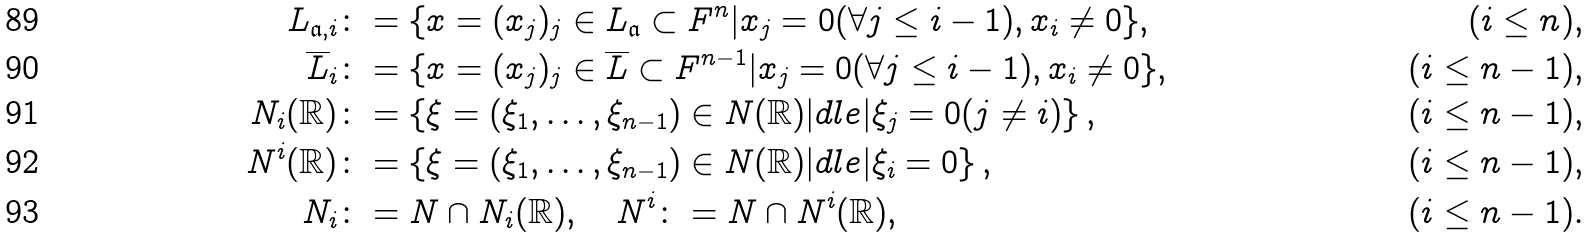<formula> <loc_0><loc_0><loc_500><loc_500>L _ { \mathfrak a , i } & \colon = \{ x = ( x _ { j } ) _ { j } \in L _ { \mathfrak a } \subset F ^ { n } | x _ { j } = 0 ( \forall j \leq i - 1 ) , x _ { i } \neq 0 \} , & ( i \leq n ) , \\ \overline { L } _ { i } & \colon = \{ x = ( x _ { j } ) _ { j } \in \overline { L } \subset F ^ { n - 1 } | x _ { j } = 0 ( \forall j \leq i - 1 ) , x _ { i } \neq 0 \} , & ( i \leq n - 1 ) , \\ N _ { i } ( \mathbb { R } ) & \colon = \left \{ \xi = ( \xi _ { 1 } , \dots , \xi _ { n - 1 } ) \in N ( \mathbb { R } ) | d l e | \xi _ { j } = 0 ( j \neq i ) \right \} , & ( i \leq n - 1 ) , \\ N ^ { i } ( \mathbb { R } ) & \colon = \left \{ \xi = ( \xi _ { 1 } , \dots , \xi _ { n - 1 } ) \in N ( \mathbb { R } ) | d l e | \xi _ { i } = 0 \right \} , & ( i \leq n - 1 ) , \\ N _ { i } & \colon = N \cap N _ { i } ( \mathbb { R } ) , \quad N ^ { i } \colon = N \cap N ^ { i } ( \mathbb { R } ) , & ( i \leq n - 1 ) .</formula> 